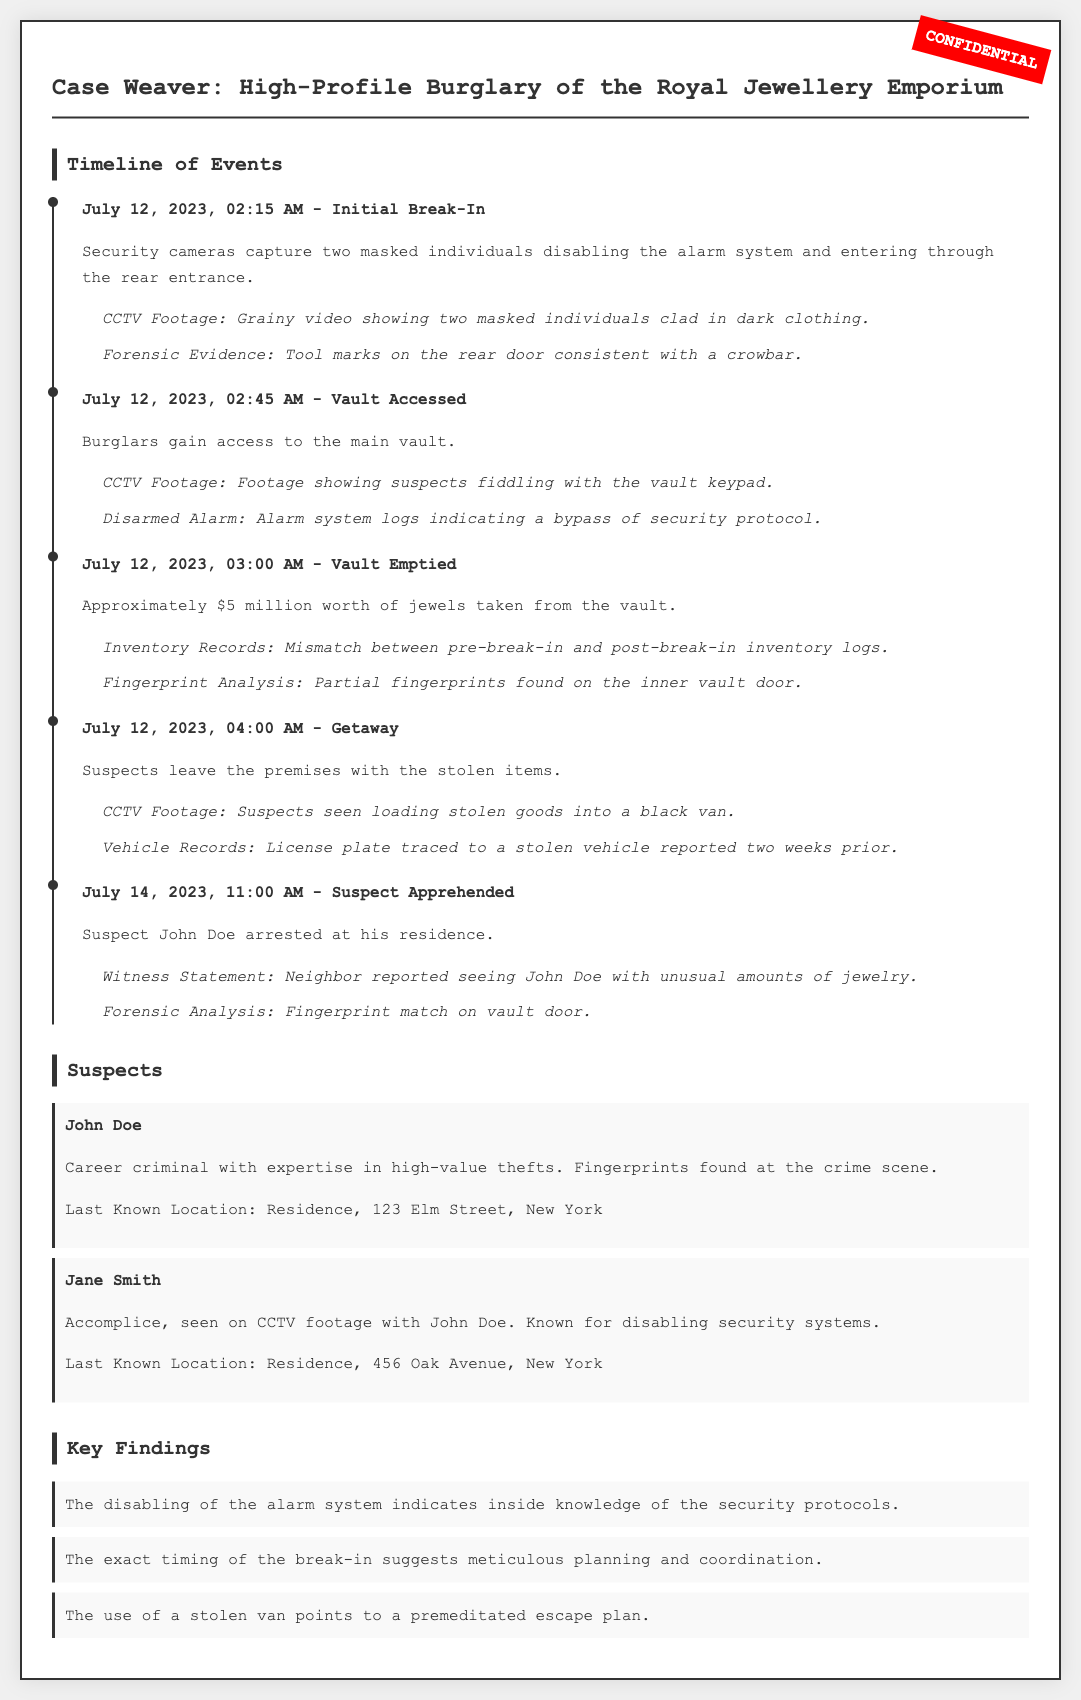What date did the burglary occur? The document states that the burglary took place on July 12, 2023.
Answer: July 12, 2023 Who is the suspect arrested at his residence? The document mentions that John Doe was the suspect arrested at his residence.
Answer: John Doe How much was the value of the jewels taken from the vault? The document specifies that approximately $5 million worth of jewels were taken from the vault.
Answer: $5 million What tool was identified for the break-in? The forensic evidence indicated that tool marks on the rear door were consistent with a crowbar.
Answer: Crowbar What indicates inside knowledge of the security protocols? The disabling of the alarm system indicates inside knowledge of the security protocols as detailed in the findings.
Answer: Disabling of the alarm system Which stolen vehicle was traced during the investigation? The document states that the license plate of a black van was traced to a stolen vehicle reported two weeks prior.
Answer: Black van Who was seen on CCTV footage with John Doe? The document indicates that Jane Smith was the accomplice seen on CCTV footage with John Doe.
Answer: Jane Smith What is the last known location of John Doe? The document provides John Doe's last known location as his residence at 123 Elm Street, New York.
Answer: 123 Elm Street, New York 